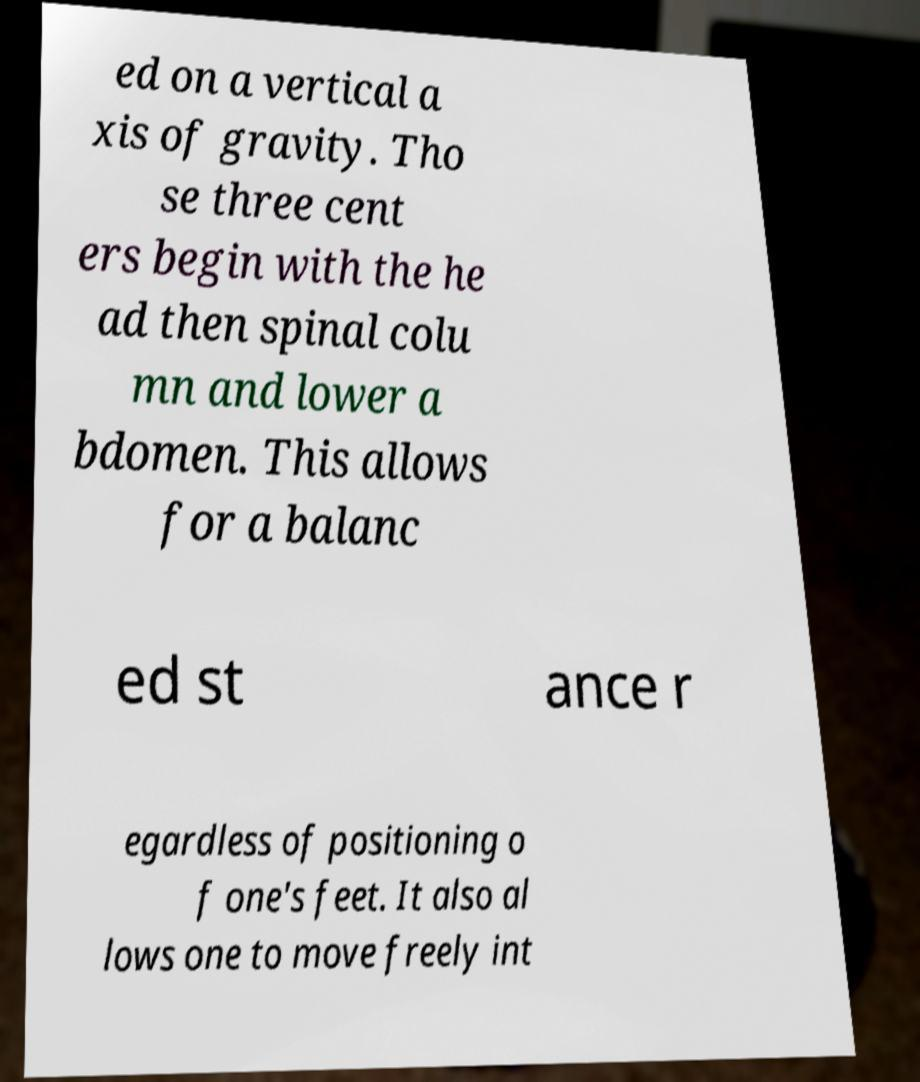Can you accurately transcribe the text from the provided image for me? ed on a vertical a xis of gravity. Tho se three cent ers begin with the he ad then spinal colu mn and lower a bdomen. This allows for a balanc ed st ance r egardless of positioning o f one's feet. It also al lows one to move freely int 